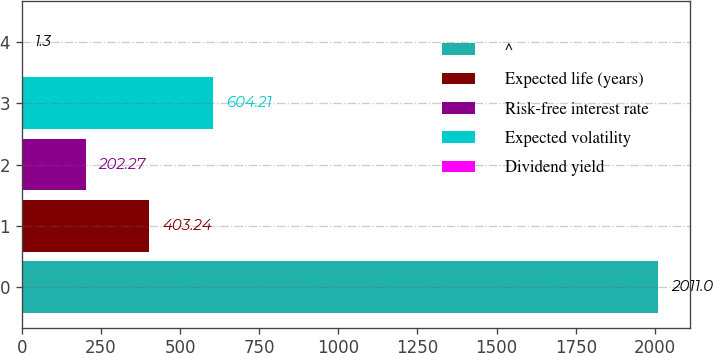Convert chart. <chart><loc_0><loc_0><loc_500><loc_500><bar_chart><fcel>^<fcel>Expected life (years)<fcel>Risk-free interest rate<fcel>Expected volatility<fcel>Dividend yield<nl><fcel>2011<fcel>403.24<fcel>202.27<fcel>604.21<fcel>1.3<nl></chart> 